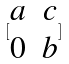Convert formula to latex. <formula><loc_0><loc_0><loc_500><loc_500>[ \begin{matrix} a & c \\ 0 & b \end{matrix} ]</formula> 